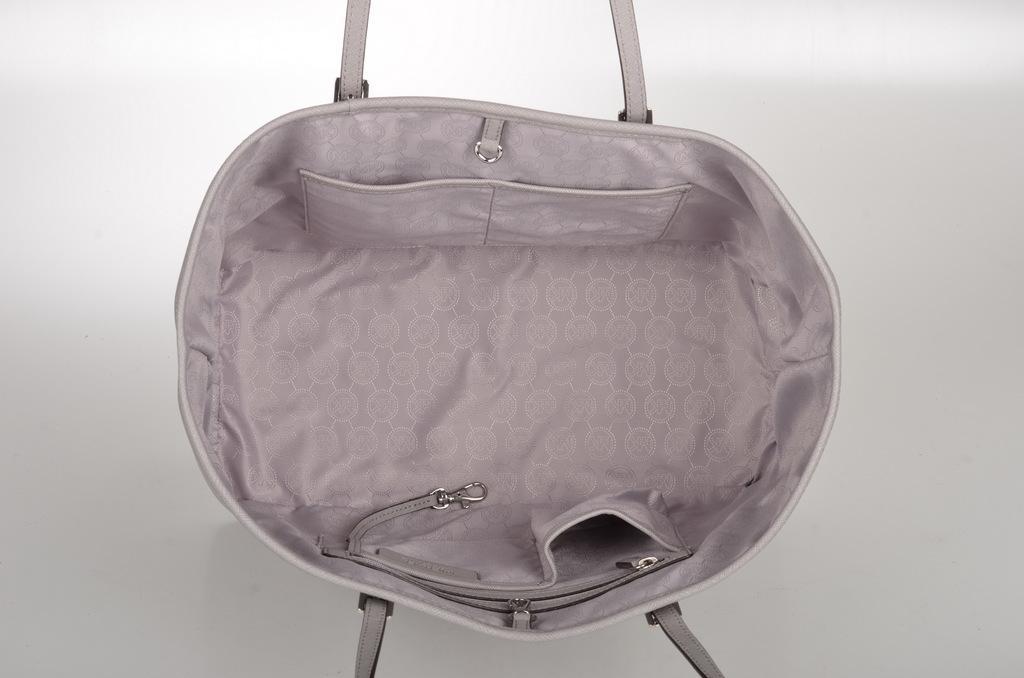Please provide a concise description of this image. In this picture we can see a bag. 